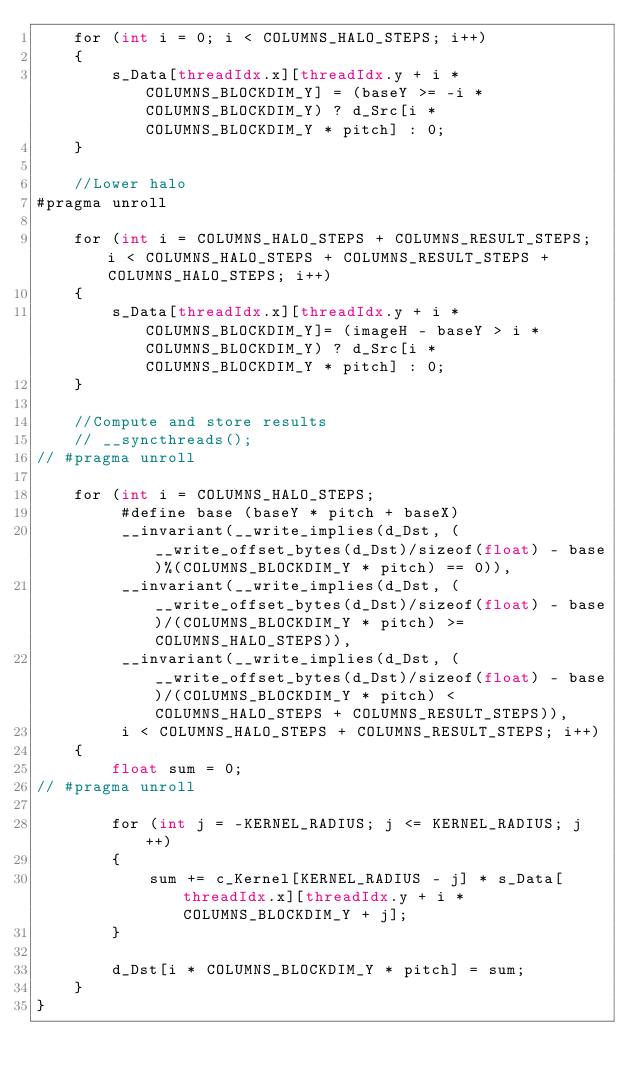<code> <loc_0><loc_0><loc_500><loc_500><_Cuda_>    for (int i = 0; i < COLUMNS_HALO_STEPS; i++)
    {
        s_Data[threadIdx.x][threadIdx.y + i * COLUMNS_BLOCKDIM_Y] = (baseY >= -i * COLUMNS_BLOCKDIM_Y) ? d_Src[i * COLUMNS_BLOCKDIM_Y * pitch] : 0;
    }

    //Lower halo
#pragma unroll

    for (int i = COLUMNS_HALO_STEPS + COLUMNS_RESULT_STEPS; i < COLUMNS_HALO_STEPS + COLUMNS_RESULT_STEPS + COLUMNS_HALO_STEPS; i++)
    {
        s_Data[threadIdx.x][threadIdx.y + i * COLUMNS_BLOCKDIM_Y]= (imageH - baseY > i * COLUMNS_BLOCKDIM_Y) ? d_Src[i * COLUMNS_BLOCKDIM_Y * pitch] : 0;
    }

    //Compute and store results
    // __syncthreads();
// #pragma unroll

    for (int i = COLUMNS_HALO_STEPS;
         #define base (baseY * pitch + baseX)
         __invariant(__write_implies(d_Dst, (__write_offset_bytes(d_Dst)/sizeof(float) - base)%(COLUMNS_BLOCKDIM_Y * pitch) == 0)),
         __invariant(__write_implies(d_Dst, (__write_offset_bytes(d_Dst)/sizeof(float) - base)/(COLUMNS_BLOCKDIM_Y * pitch) >= COLUMNS_HALO_STEPS)),
         __invariant(__write_implies(d_Dst, (__write_offset_bytes(d_Dst)/sizeof(float) - base)/(COLUMNS_BLOCKDIM_Y * pitch) < COLUMNS_HALO_STEPS + COLUMNS_RESULT_STEPS)),
         i < COLUMNS_HALO_STEPS + COLUMNS_RESULT_STEPS; i++)
    {
        float sum = 0;
// #pragma unroll

        for (int j = -KERNEL_RADIUS; j <= KERNEL_RADIUS; j++)
        {
            sum += c_Kernel[KERNEL_RADIUS - j] * s_Data[threadIdx.x][threadIdx.y + i * COLUMNS_BLOCKDIM_Y + j];
        }

        d_Dst[i * COLUMNS_BLOCKDIM_Y * pitch] = sum;
    }
}
</code> 